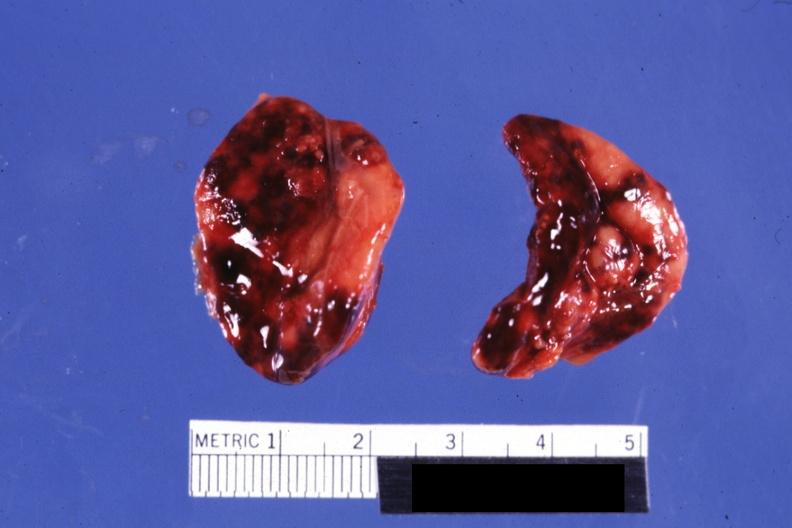what looks like placental abruption?
Answer the question using a single word or phrase. History 